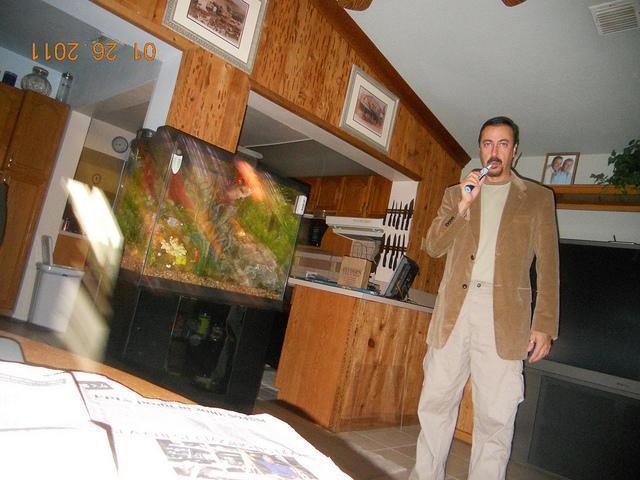How many cats with spots do you see?
Give a very brief answer. 0. 